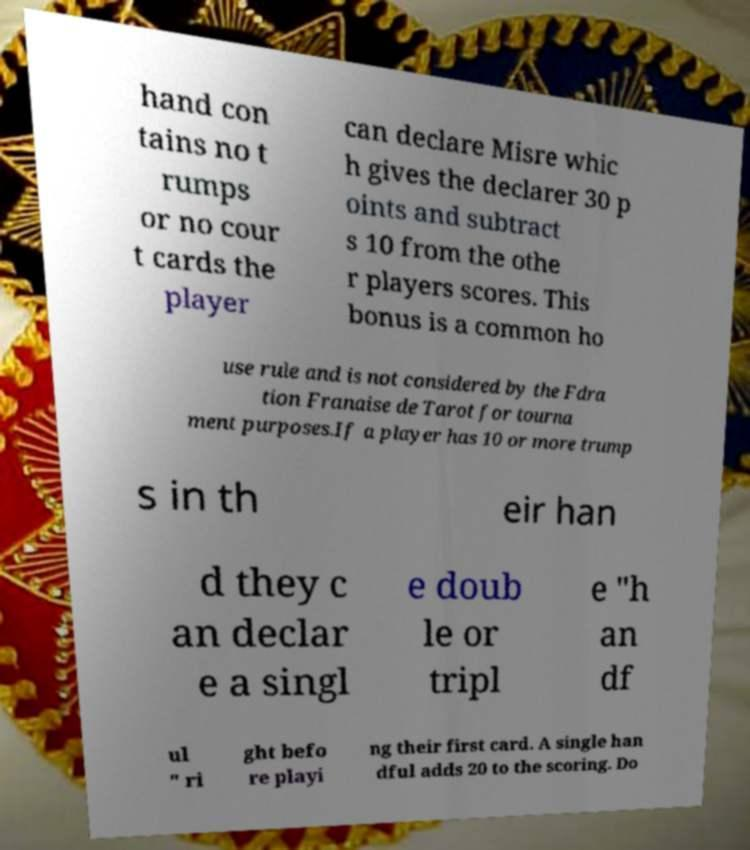Could you assist in decoding the text presented in this image and type it out clearly? hand con tains no t rumps or no cour t cards the player can declare Misre whic h gives the declarer 30 p oints and subtract s 10 from the othe r players scores. This bonus is a common ho use rule and is not considered by the Fdra tion Franaise de Tarot for tourna ment purposes.If a player has 10 or more trump s in th eir han d they c an declar e a singl e doub le or tripl e "h an df ul " ri ght befo re playi ng their first card. A single han dful adds 20 to the scoring. Do 